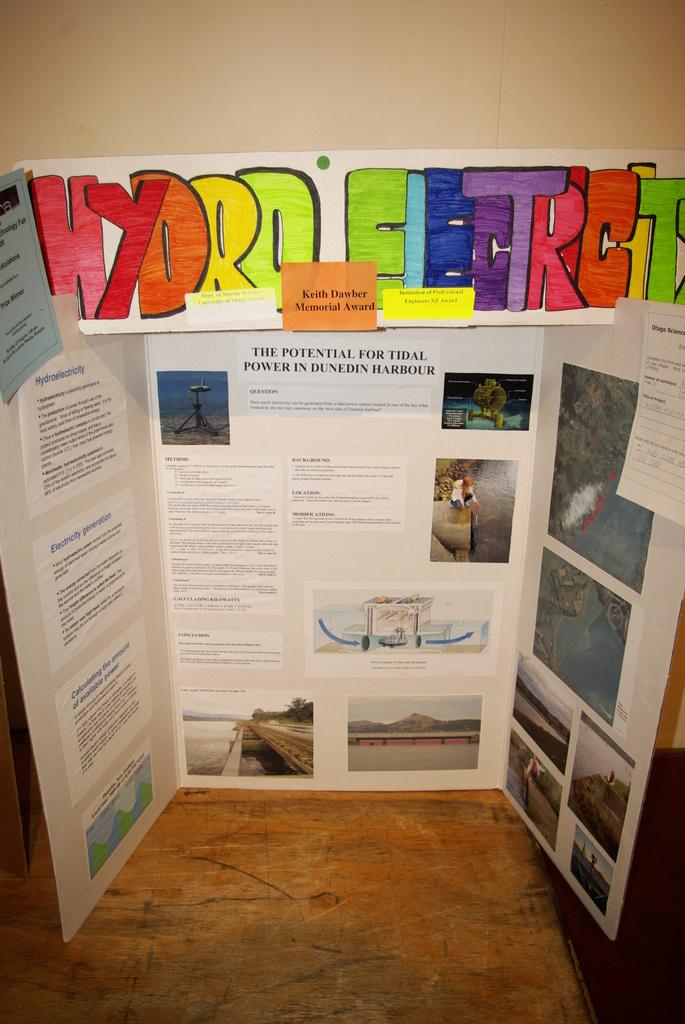<image>
Describe the image concisely. a posterboard with one topic in the middle about the potential for tideal power in dunedin harbor 